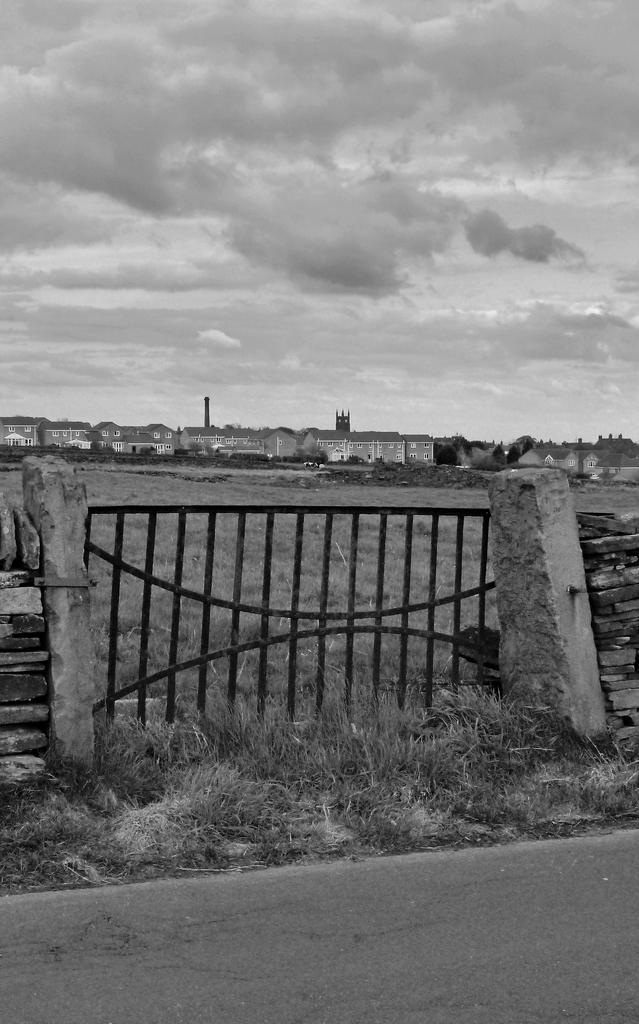What type of barrier can be seen in the image? There is a fence in the image. What type of vegetation is present in the image? There is grass in the image. What can be seen in the distance in the image? There are buildings in the background of the image. What is visible in the sky in the image? The sky is visible in the background of the image. What brand of toothpaste is being advertised on the kite in the image? There is no kite or toothpaste present in the image. What part of the human body is visible in the image? There is no part of the human body visible in the image. 